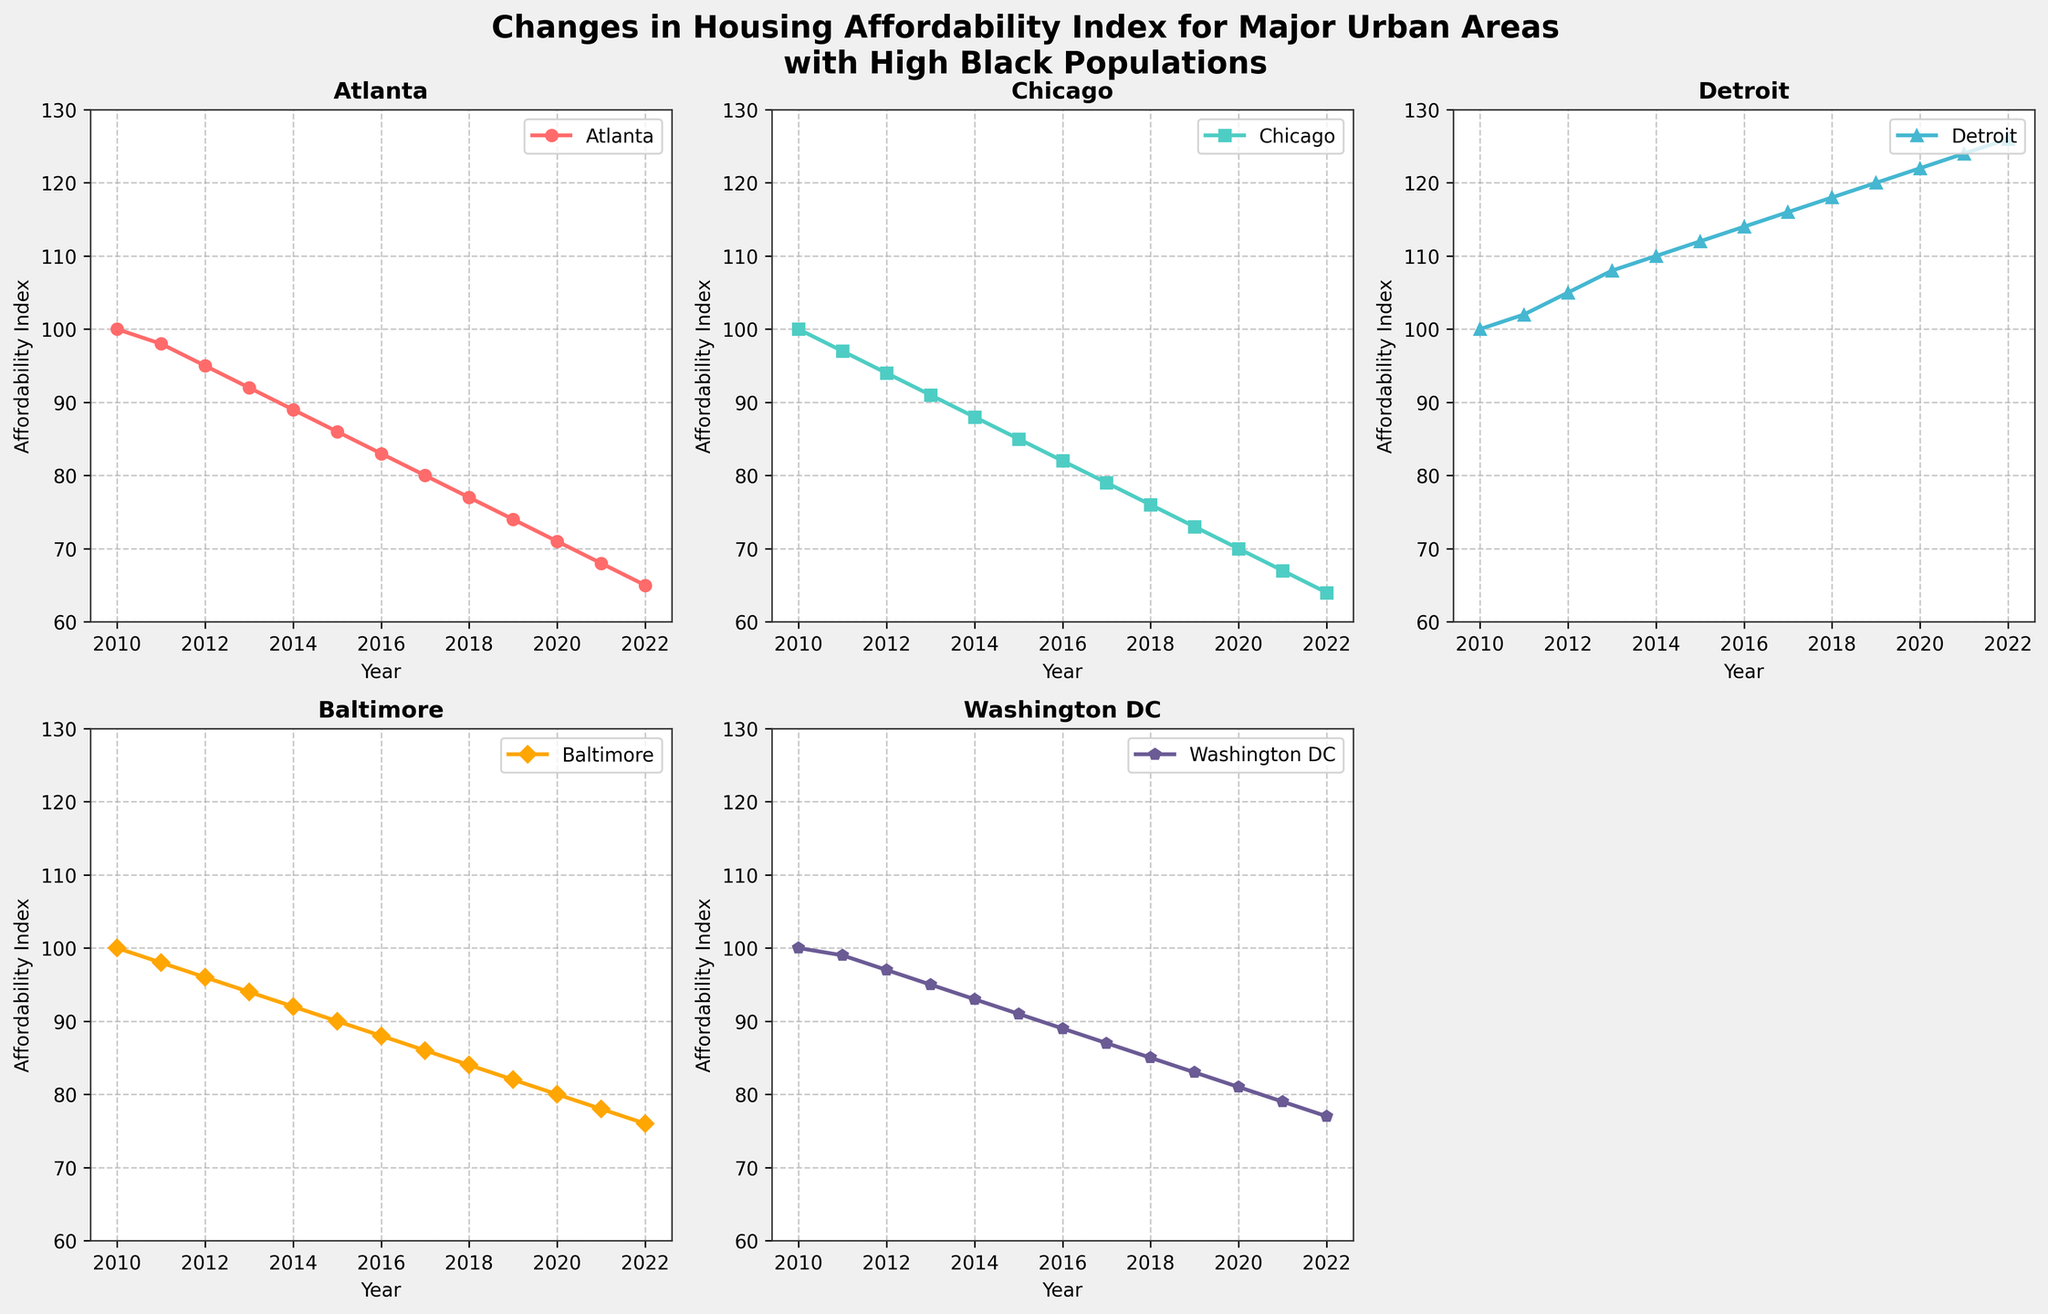What is the title of the figure? The title is located at the top of the figure and is typically larger and bolder than other text. It reads: "Changes in Housing Affordability Index for Major Urban Areas with High Black Populations"
Answer: Changes in Housing Affordability Index for Major Urban Areas with High Black Populations How many subplots are visible in the figure? By counting the number of individual charts within the figure, we see there are 5 subplots representing different cities. The sixth subplot space is left blank.
Answer: 5 Which city experienced the most significant decrease in the Housing Affordability Index from 2010 to 2022? To determine this, compare the decrease in the Affordability Index for each city from 2010 to 2022. Chicago dropped from 100 to 64, a decrease of 36 points, which is the highest.
Answer: Chicago In which year did Detroit's Housing Affordability Index reach 118? By locating Detroit's data series and examining the Affordability Index values, we see that it reached 118 in the year 2018.
Answer: 2018 How does the trend for Washington DC's Housing Affordability Index compare to that of Baltimore from 2010 to 2022? To compare trends, look at the series for both cities. Washington DC and Baltimore both show a decline over the period, but Washington DC's index decreased from 100 to 77 while Baltimore's index decreased from 100 to 76. Both declined similarly but Washington DC's decline is slightly less steep.
Answer: Both show a decline, but Washington DC's decline is slightly less steep What is the Affordability Index value for Atlanta in 2015? Locate Atlanta's data series for the year 2015, which reveals the Affordability Index value of 86.
Answer: 86 What pattern do you observe in the Housing Affordability Index for Detroit over the years? Detroit's data series shows a consistent increase year over year, indicating rising affordability issues, ending from 100 in 2010 to 126 in 2022.
Answer: Increasing trend Which city had the highest Housing Affordability Index in the year 2020? By comparing the Affordability Index of all cities in the year 2020, Detroit has the highest index of 122.
Answer: Detroit Is there any year where the Housing Affordability Index for all cities is equal or very close? In 2010, all cities start with an Affordability Index of 100. This is the only point where their values are equal.
Answer: 2010 